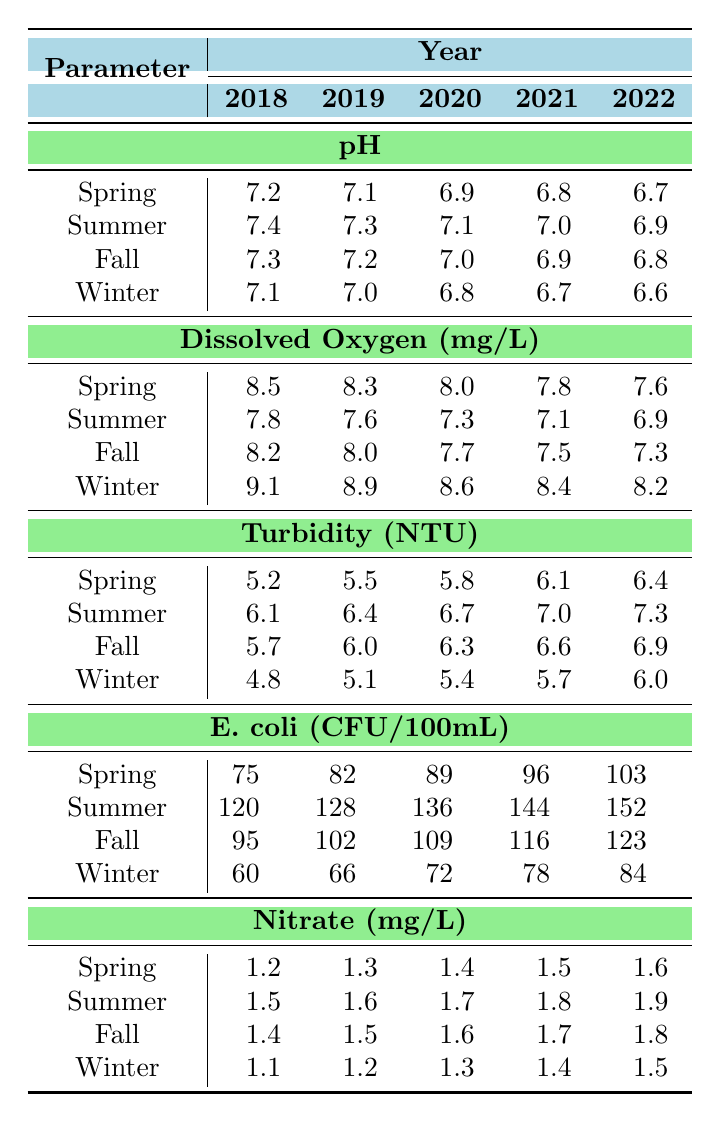What was the pH level in Winter of 2022? The table shows the pH levels across seasons and the latest data is for the year 2022. In Winter, the pH level recorded is 6.6.
Answer: 6.6 Which season had the highest dissolved oxygen level in 2019? By examining the dissolved oxygen values for each season in 2019, Spring had the highest level at 8.3 mg/L.
Answer: Spring What is the difference in E. coli levels between Spring and Fall in 2020? In 2020, Spring recorded 89 CFU/100mL and Fall recorded 109 CFU/100mL. The difference can be calculated as 109 - 89 = 20 CFU/100mL.
Answer: 20 What is the average turbidity level across all seasons in Summer for the years 2018 to 2022? To find the average turbidity for Summer, we add the values from each year: (6.1 + 6.4 + 6.7 + 7.0 + 7.3) = 33.5. Then divide by 5, giving us an average of 33.5 / 5 = 6.7 NTU.
Answer: 6.7 Was there a decreasing trend in the pH levels from Spring to Winter in 2022? By comparing the pH levels for each season in 2022: Spring (6.7), Summer (6.9), Fall (6.8), and Winter (6.6), you can observe that they decrease from Spring to Winter with small fluctuations, confirming a mostly decreasing trend overall.
Answer: Yes What year had the lowest dissolved oxygen level in Fall? Looking at the Fall dissolved oxygen levels across the years, 2022 shows the lowest value at 7.3 mg/L.
Answer: 2022 Calculate the total nitrate levels across all seasons for the year 2021. The nitrate levels in 2021 for each season are Spring (1.5), Summer (1.8), Fall (1.7), and Winter (1.4). Adding these together gives 1.5 + 1.8 + 1.7 + 1.4 = 6.4 mg/L.
Answer: 6.4 In which season did E. coli levels consistently increase from 2018 to 2022? By examining the E. coli values for each year and finding trends, Summer shows that E. coli levels increased each year: 120 (2018), 128 (2019), 136 (2020), 144 (2021), and 152 (2022).
Answer: Summer Is it true that Winter had the highest turbidity level in 2021? In the table, Winter's turbidity for 2021 is 5.7 NTU, which is lower than in Spring (6.8), Summer (7.0), and Fall (6.9), therefore it is false that Winter had the highest turbidity that year.
Answer: No What was the trend in Summer pH levels from 2018 to 2022? The Summer pH levels are: 7.4 (2018), 7.3 (2019), 7.1 (2020), 7.0 (2021), 6.9 (2022). Observing these values shows a steady decrease each year.
Answer: Decreasing 